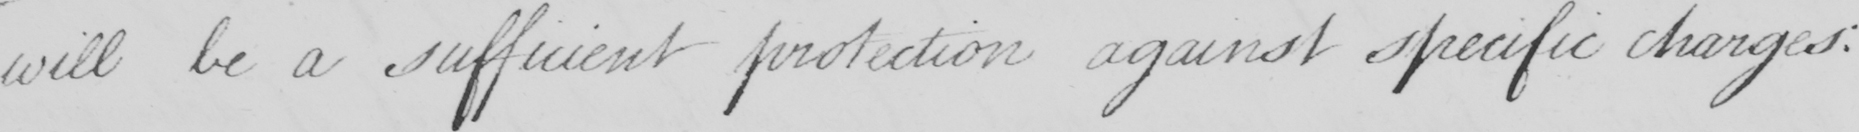Please provide the text content of this handwritten line. will be a sufficient protection against specific charges : 